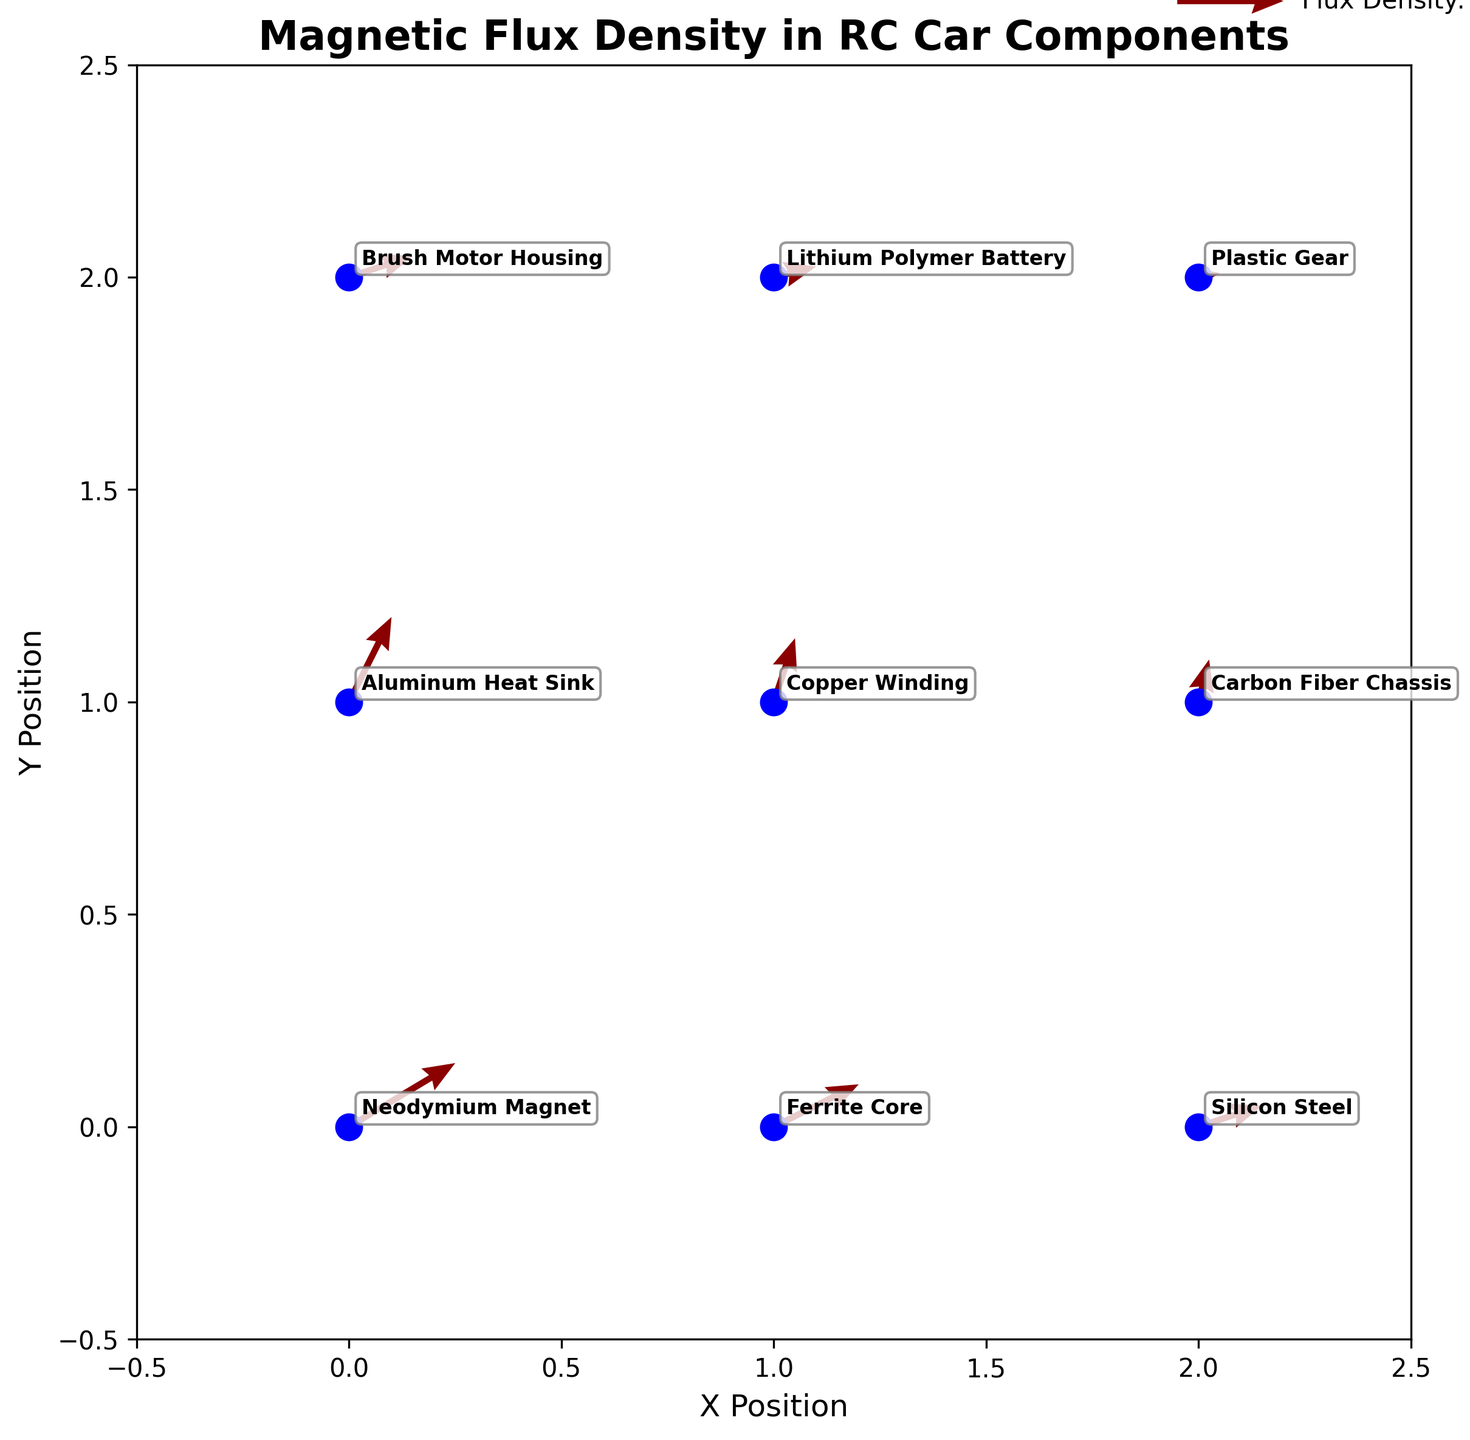What is the title of the figure? The title of the figure is displayed at the top of the plot. It reads "Magnetic Flux Density in RC Car Components".
Answer: Magnetic Flux Density in RC Car Components What is the y-coordinate of the Aluminum Heat Sink? By looking at the figure, the Aluminum Heat Sink is labeled at (0, 1), indicating that its y-coordinate is 1.
Answer: 1 Which component has the largest magnetic flux density vector? The length of the arrows represents the magnitude of the flux density vector. The largest arrow is at (0,0) corresponding to the Neodymium Magnet component.
Answer: Neodymium Magnet How many different materials are displayed in the plot? Each arrow represents a different material, and there are labels with unique material names. Counting these, there are 9 different materials displayed in the plot.
Answer: 9 What are the coordinates of the Copper Winding on the plot? The Copper Winding is located at (1, 1), as indicated by the label in that position on the plot.
Answer: (1, 1) Which material has the lowest flux density vector magnitude? The magnitude of the flux density vector can be assessed from the length of the arrows. The shortest arrow is at (2, 2), which corresponds to the Plastic Gear.
Answer: Plastic Gear Compare the flux density vectors of the Ferrite Core and the Silicon Steel. Which is larger? By comparing the lengths of the arrows at (1,0) for Ferrite Core and (2,0) for Silicon Steel, the Ferrite Core has a larger vector.
Answer: Ferrite Core What is the total magnetic flux density in the y-direction at (0,2) and (2,1)? The magnetic flux density in the y-direction at (0,2) is 0.1, and at (2,1) it is 0.2. Adding these together gives 0.3.
Answer: 0.3 Is the flux density vector at the position (1,2) stronger in the x-direction or the y-direction? The vector components at (1,2) are (0.2, 0.05). The x-direction component (0.2) is larger than the y-direction component (0.05).
Answer: x-direction What is the x-component of the flux density vector for the Lithium Polymer Battery? The Lithium Polymer Battery is located at (1, 2). The x-component of its flux density vector is 0.2, as given in the data.
Answer: 0.2 